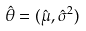Convert formula to latex. <formula><loc_0><loc_0><loc_500><loc_500>\hat { \theta } = ( \hat { \mu } , \hat { \sigma } ^ { 2 } )</formula> 